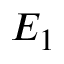<formula> <loc_0><loc_0><loc_500><loc_500>E _ { 1 }</formula> 